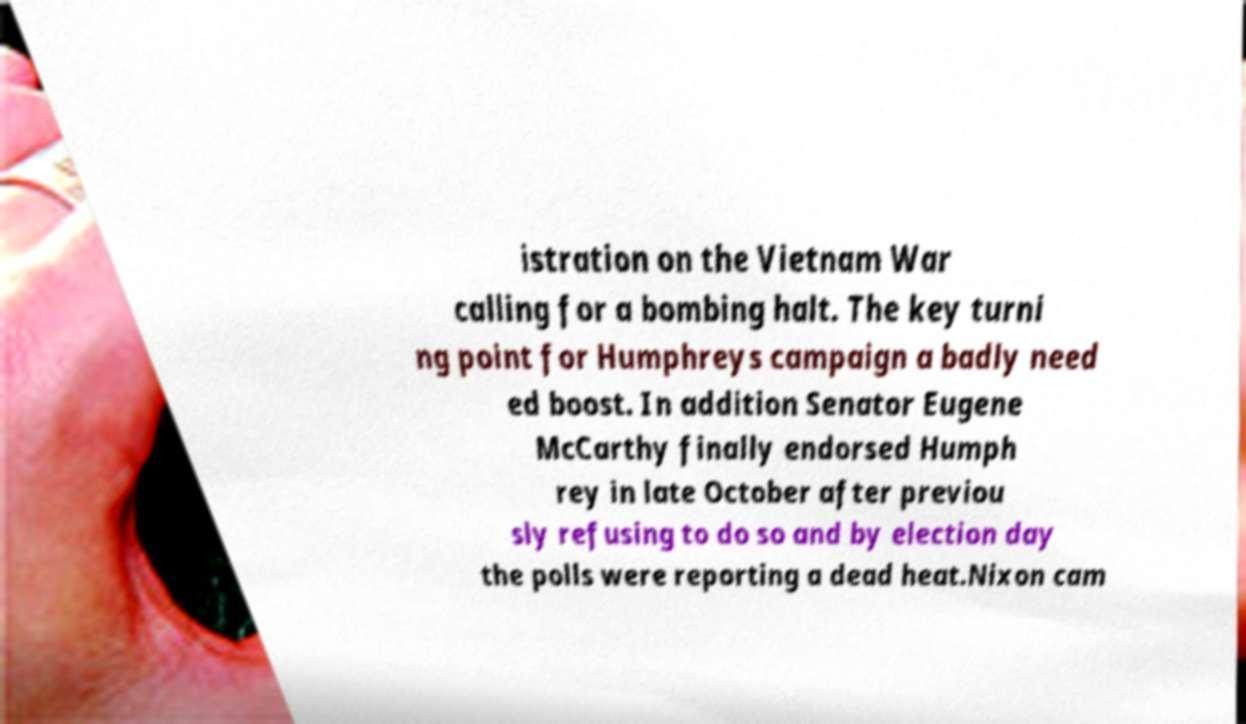Can you read and provide the text displayed in the image?This photo seems to have some interesting text. Can you extract and type it out for me? istration on the Vietnam War calling for a bombing halt. The key turni ng point for Humphreys campaign a badly need ed boost. In addition Senator Eugene McCarthy finally endorsed Humph rey in late October after previou sly refusing to do so and by election day the polls were reporting a dead heat.Nixon cam 